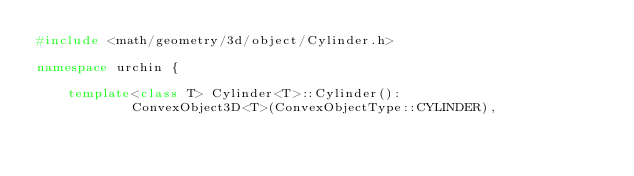<code> <loc_0><loc_0><loc_500><loc_500><_C++_>#include <math/geometry/3d/object/Cylinder.h>

namespace urchin {

    template<class T> Cylinder<T>::Cylinder():
            ConvexObject3D<T>(ConvexObjectType::CYLINDER),</code> 